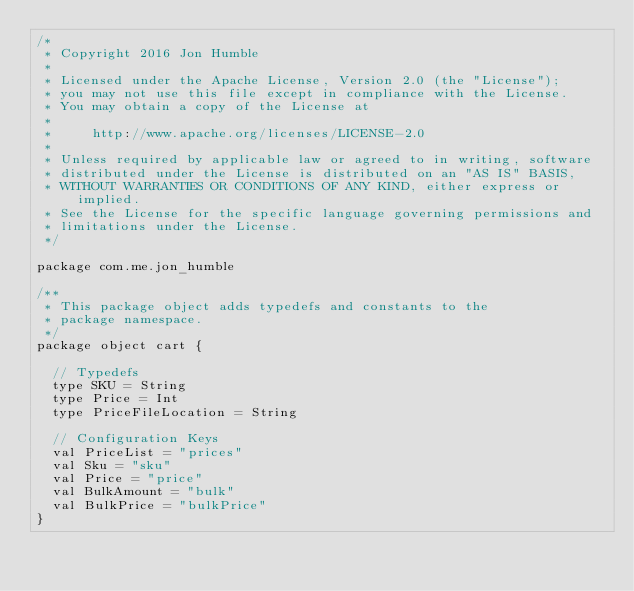Convert code to text. <code><loc_0><loc_0><loc_500><loc_500><_Scala_>/*
 * Copyright 2016 Jon Humble
 *
 * Licensed under the Apache License, Version 2.0 (the "License");
 * you may not use this file except in compliance with the License.
 * You may obtain a copy of the License at
 *
 *     http://www.apache.org/licenses/LICENSE-2.0
 *
 * Unless required by applicable law or agreed to in writing, software
 * distributed under the License is distributed on an "AS IS" BASIS,
 * WITHOUT WARRANTIES OR CONDITIONS OF ANY KIND, either express or implied.
 * See the License for the specific language governing permissions and
 * limitations under the License.
 */

package com.me.jon_humble

/**
 * This package object adds typedefs and constants to the
 * package namespace.
 */
package object cart {

  // Typedefs
  type SKU = String
  type Price = Int
  type PriceFileLocation = String

  // Configuration Keys
  val PriceList = "prices"
  val Sku = "sku"
  val Price = "price"
  val BulkAmount = "bulk"
  val BulkPrice = "bulkPrice"
}
</code> 